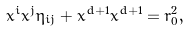<formula> <loc_0><loc_0><loc_500><loc_500>x ^ { i } x ^ { j } \eta _ { i j } + x ^ { d + 1 } x ^ { d + 1 } = r _ { 0 } ^ { 2 } ,</formula> 